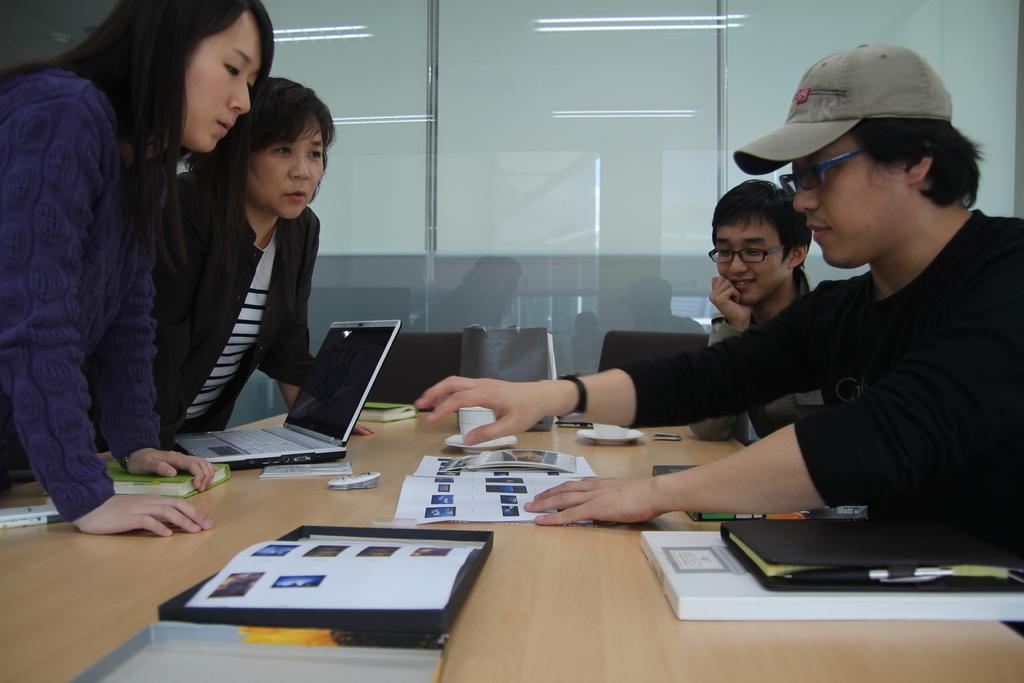Describe this image in one or two sentences. In this image we can see four persons, two men are standing and two women were sitting, there is a table, on the table there is a laptop, papers and books. 